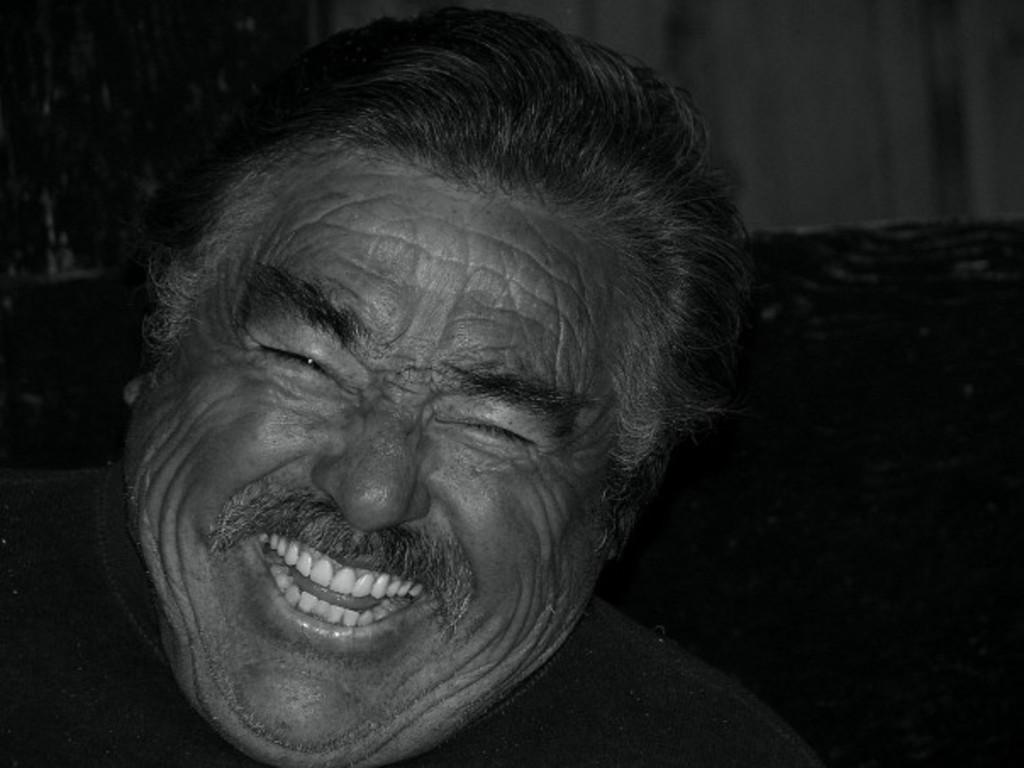What is the color scheme of the image? The image is black and white. Who is present in the image? There is a man in the image. What is the man doing in the image? The man is smiling in the image. What type of soda is the man holding in the image? There is no soda present in the image; it is a black and white image of a man smiling. How deep is the hole in the image? There is no hole present in the image; it is a black and white image of a man smiling. 